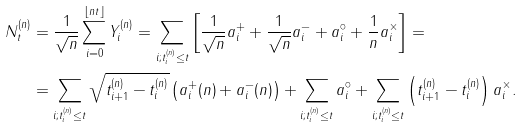Convert formula to latex. <formula><loc_0><loc_0><loc_500><loc_500>N _ { t } ^ { ( n ) } & = \frac { 1 } { \sqrt { n } } \sum _ { i = 0 } ^ { \lfloor n t \rfloor } Y _ { i } ^ { ( n ) } = \sum _ { i ; t _ { i } ^ { ( n ) } \leq t } \left [ \frac { 1 } { \sqrt { n } } a _ { i } ^ { + } + \frac { 1 } { \sqrt { n } } a _ { i } ^ { - } + a _ { i } ^ { \circ } + \frac { 1 } { n } a _ { i } ^ { \times } \right ] = \\ & = \sum _ { i ; t _ { i } ^ { ( n ) } \leq t } \sqrt { t _ { i + 1 } ^ { ( n ) } - t _ { i } ^ { ( n ) } } \left ( a _ { i } ^ { + } ( n ) + a _ { i } ^ { - } ( n ) \right ) + \sum _ { i ; t _ { i } ^ { ( n ) } \leq t } a _ { i } ^ { \circ } + \sum _ { i ; t _ { i } ^ { ( n ) } \leq t } \left ( t _ { i + 1 } ^ { ( n ) } - t _ { i } ^ { ( n ) } \right ) a _ { i } ^ { \times } .</formula> 